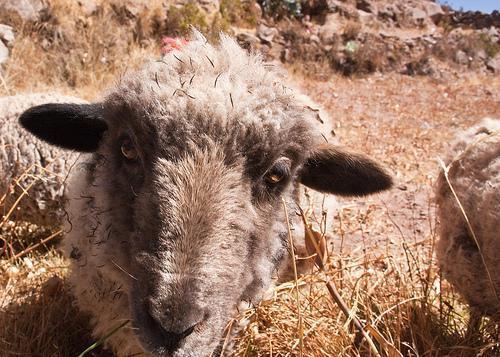How many sheep are there?
Give a very brief answer. 3. 